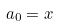<formula> <loc_0><loc_0><loc_500><loc_500>a _ { 0 } = x</formula> 